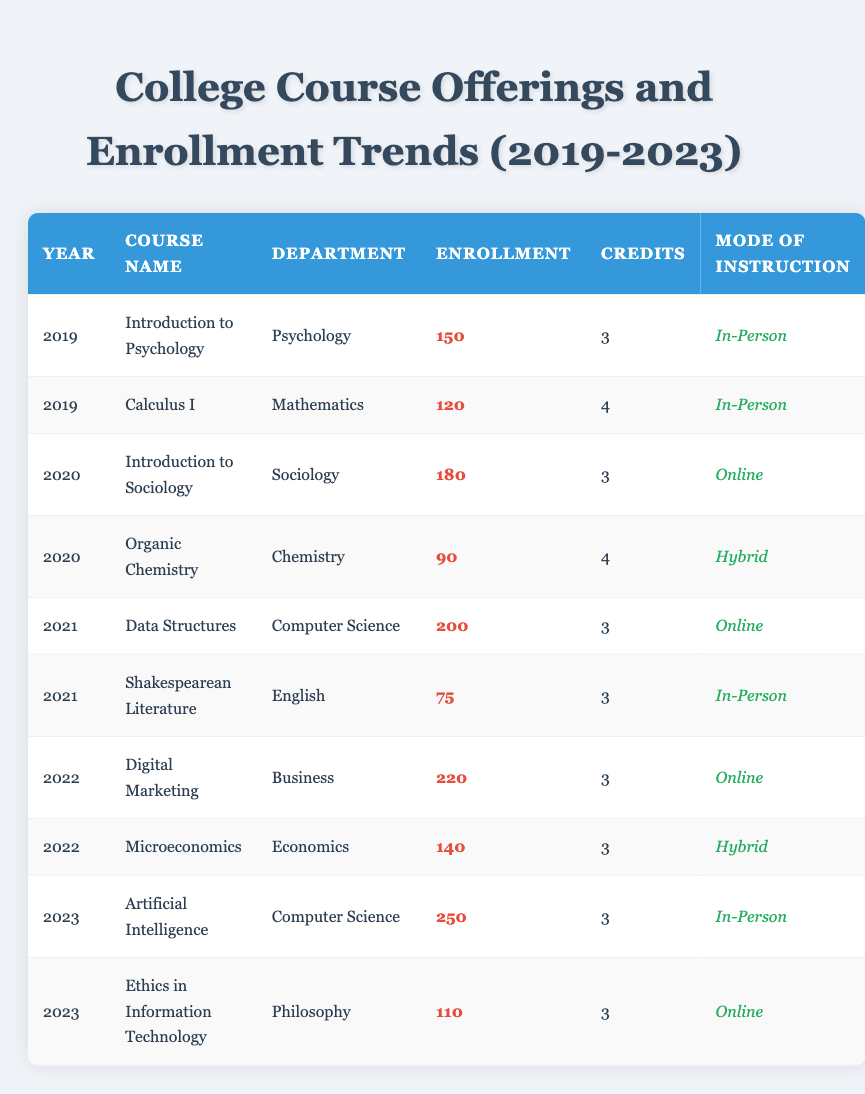What was the enrollment for "Calculus I" in 2019? The table shows that for the year 2019, the course "Calculus I" in the Mathematics department has an enrollment of 120 students as listed directly beneath the year.
Answer: 120 Which course had the highest enrollment in 2022? In 2022, the table lists two courses: "Digital Marketing" with an enrollment of 220 and "Microeconomics" with 140 students. The highest enrollment is 220 for "Digital Marketing."
Answer: Digital Marketing True or False: "Artificial Intelligence" was offered in 2022. The data shows that "Artificial Intelligence" was offered in 2023. Therefore, the statement is false as it is not listed under the year 2022.
Answer: False What is the total enrollment for all courses offered in 2023? Looking at the enrollment numbers for the year 2023, "Artificial Intelligence" has 250 and "Ethics in Information Technology" has 110. Adding these gives a total enrollment of 250 + 110 = 360 for 2023.
Answer: 360 What is the average enrollment for courses listed in 2021? The courses offered in 2021 are "Data Structures" with 200 and "Shakespearean Literature" with 75. First, we sum these enrollments: 200 + 75 = 275. Then, divide by the number of courses (2) to find the average: 275 / 2 = 137.5.
Answer: 137.5 For how many courses was the mode of instruction "Online" in 2020? The year 2020 features two courses: "Introduction to Sociology" (Online) and "Organic Chemistry" (Hybrid). Only one course, "Introduction to Sociology," is online. Therefore, there is one course with the online instruction mode in 2020.
Answer: 1 Which department had the lowest enrollment in a single course and what was that enrollment? Examining each year's enrollment figures reveals that "Shakespearean Literature" from the English department had the lowest enrollment with 75. This is the lowest single course enrollment across all departments listed in the table.
Answer: English, 75 What trend can be seen in course offerings and enrollment growth from 2019 to 2023? Referring to the enrollment numbers, there is a noticeable upward trend: 150 in 2019, 180 in 2020, 200 in 2021, 220 in 2022, and finally 250 in 2023. This indicates an increasing interest or growth in course enrollment over these years.
Answer: Increasing enrollment trend 